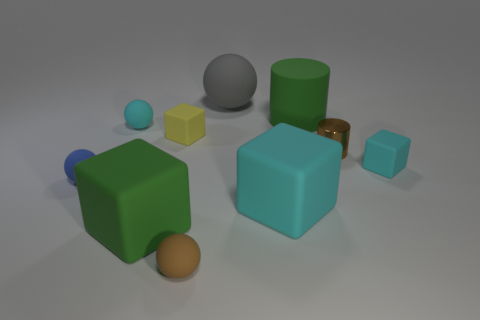Is there a green cylinder that has the same material as the tiny brown ball?
Offer a terse response. Yes. What material is the block that is behind the tiny shiny cylinder?
Provide a short and direct response. Rubber. There is a tiny matte sphere behind the shiny cylinder; is it the same color as the small cube in front of the small metallic object?
Your answer should be very brief. Yes. What color is the cylinder that is the same size as the blue rubber sphere?
Keep it short and to the point. Brown. How many other objects are the same shape as the tiny blue thing?
Make the answer very short. 3. There is a green thing that is in front of the brown cylinder; what is its size?
Give a very brief answer. Large. There is a small cyan thing that is to the right of the tiny cyan matte ball; what number of small cyan cubes are to the left of it?
Your answer should be compact. 0. How many other objects are there of the same size as the gray matte object?
Make the answer very short. 3. Is the matte cylinder the same color as the small shiny cylinder?
Provide a short and direct response. No. There is a large thing that is to the left of the gray matte sphere; is it the same shape as the blue object?
Ensure brevity in your answer.  No. 